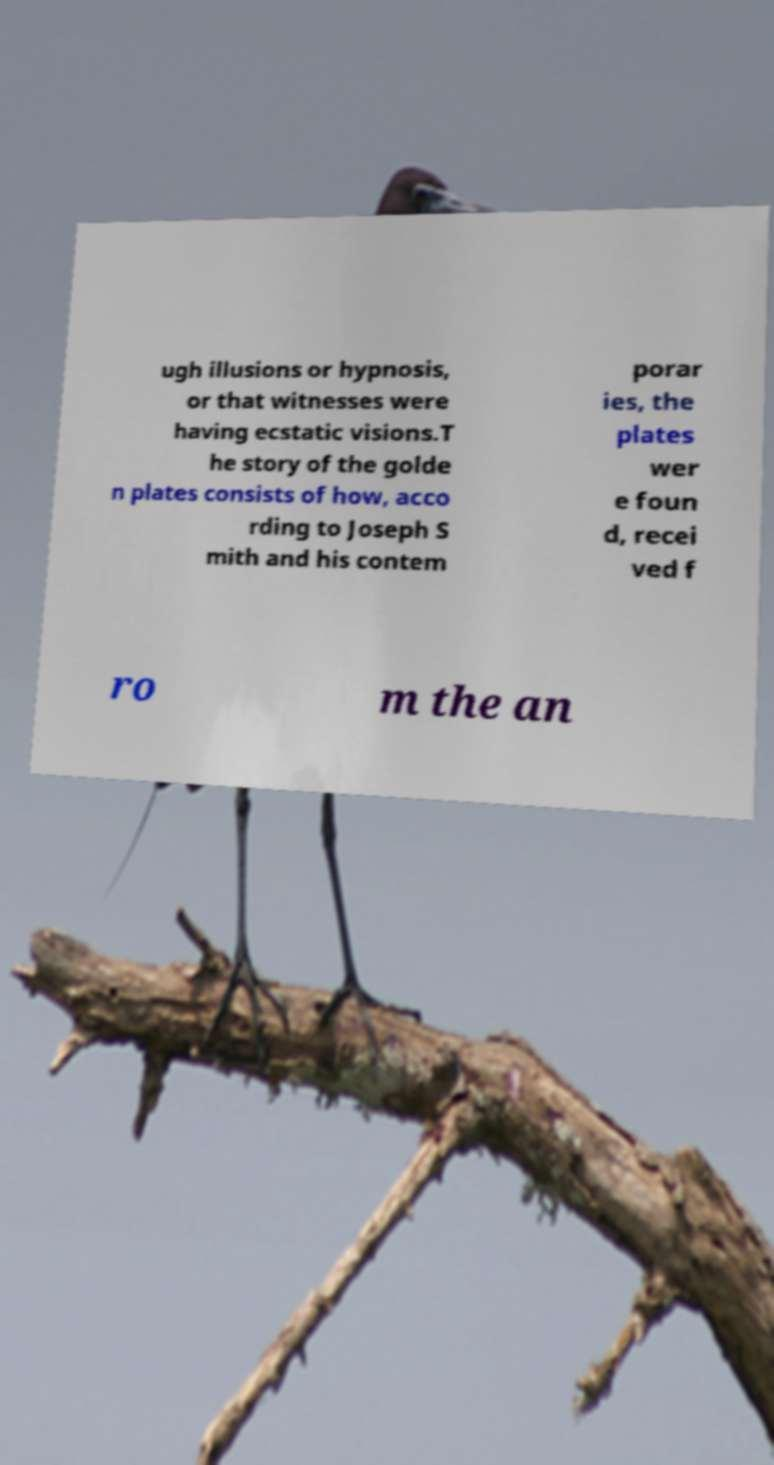Please read and relay the text visible in this image. What does it say? ugh illusions or hypnosis, or that witnesses were having ecstatic visions.T he story of the golde n plates consists of how, acco rding to Joseph S mith and his contem porar ies, the plates wer e foun d, recei ved f ro m the an 